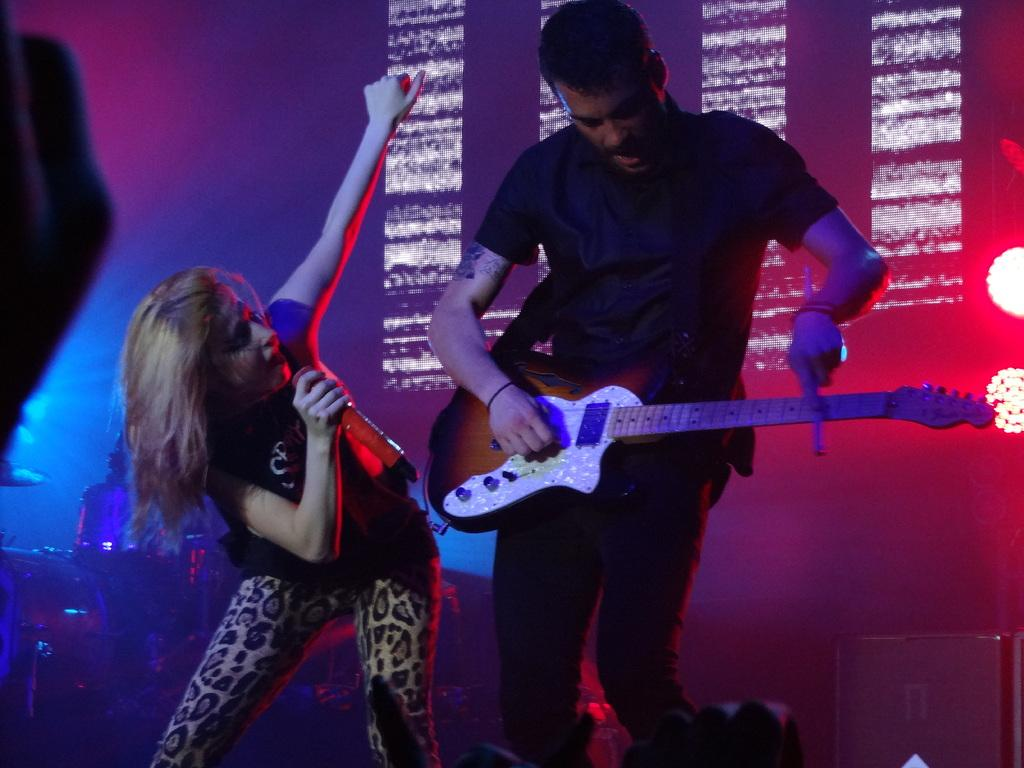What is the man in the image doing? The man is standing and holding a guitar in his hand. Who else is present in the image? There is a woman in the image. What is the woman holding in her hand? The woman is holding a microphone in her hand. What type of sponge can be seen playing the instrument in the image? There is no sponge present in the image, and no instrument is being played by a sponge. 